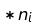<formula> <loc_0><loc_0><loc_500><loc_500>* n _ { i }</formula> 